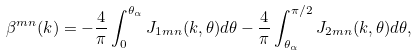<formula> <loc_0><loc_0><loc_500><loc_500>\beta ^ { m n } ( k ) = - \frac { 4 } { \pi } \int _ { 0 } ^ { \theta _ { \alpha } } J _ { 1 m n } ( k , \theta ) d \theta - \frac { 4 } { \pi } \int _ { \theta _ { \alpha } } ^ { \pi / 2 } J _ { 2 m n } ( k , \theta ) d \theta ,</formula> 